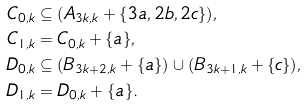<formula> <loc_0><loc_0><loc_500><loc_500>C _ { 0 , k } & \subseteq ( A _ { 3 k , k } + \{ 3 a , 2 b , 2 c \} ) , \\ C _ { 1 , k } & = C _ { 0 , k } + \{ a \} , \\ D _ { 0 , k } & \subseteq ( B _ { 3 k + 2 , k } + \{ a \} ) \cup ( B _ { 3 k + 1 , k } + \{ c \} ) , \\ D _ { 1 , k } & = D _ { 0 , k } + \{ a \} .</formula> 